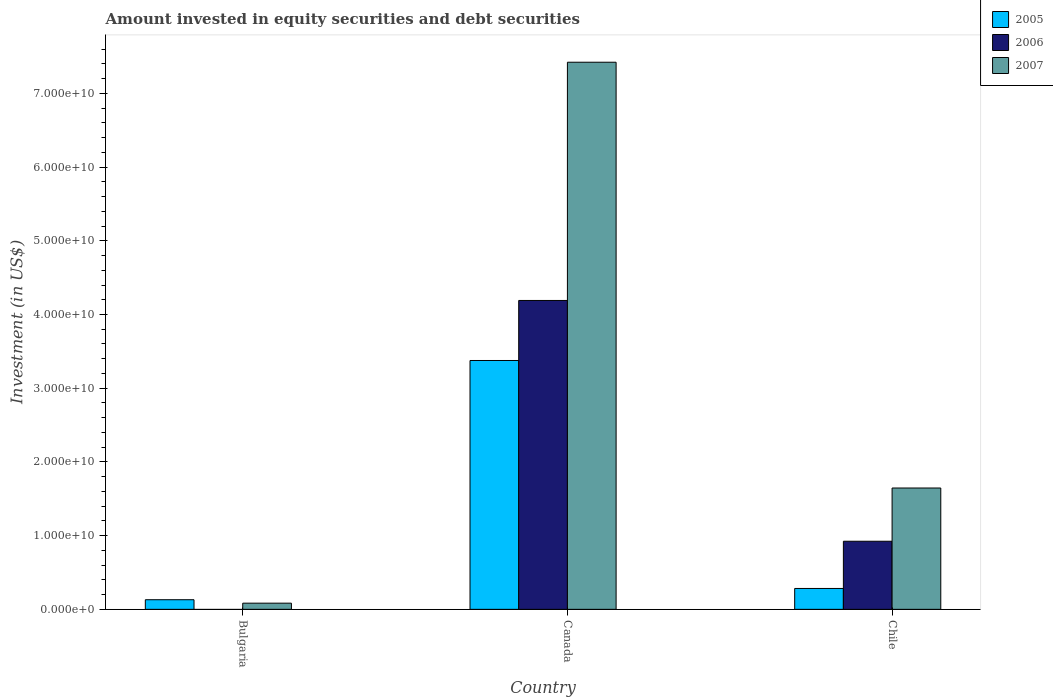How many different coloured bars are there?
Provide a short and direct response. 3. Are the number of bars per tick equal to the number of legend labels?
Provide a succinct answer. No. Are the number of bars on each tick of the X-axis equal?
Provide a succinct answer. No. How many bars are there on the 2nd tick from the left?
Provide a succinct answer. 3. How many bars are there on the 2nd tick from the right?
Provide a short and direct response. 3. What is the label of the 3rd group of bars from the left?
Offer a very short reply. Chile. In how many cases, is the number of bars for a given country not equal to the number of legend labels?
Your answer should be compact. 1. What is the amount invested in equity securities and debt securities in 2006 in Canada?
Your response must be concise. 4.19e+1. Across all countries, what is the maximum amount invested in equity securities and debt securities in 2006?
Give a very brief answer. 4.19e+1. Across all countries, what is the minimum amount invested in equity securities and debt securities in 2006?
Ensure brevity in your answer.  0. In which country was the amount invested in equity securities and debt securities in 2005 maximum?
Provide a succinct answer. Canada. What is the total amount invested in equity securities and debt securities in 2007 in the graph?
Offer a terse response. 9.15e+1. What is the difference between the amount invested in equity securities and debt securities in 2007 in Bulgaria and that in Chile?
Give a very brief answer. -1.56e+1. What is the difference between the amount invested in equity securities and debt securities in 2006 in Bulgaria and the amount invested in equity securities and debt securities in 2005 in Chile?
Provide a succinct answer. -2.83e+09. What is the average amount invested in equity securities and debt securities in 2006 per country?
Make the answer very short. 1.70e+1. What is the difference between the amount invested in equity securities and debt securities of/in 2007 and amount invested in equity securities and debt securities of/in 2006 in Chile?
Keep it short and to the point. 7.22e+09. In how many countries, is the amount invested in equity securities and debt securities in 2006 greater than 42000000000 US$?
Provide a short and direct response. 0. What is the ratio of the amount invested in equity securities and debt securities in 2006 in Canada to that in Chile?
Provide a succinct answer. 4.54. Is the amount invested in equity securities and debt securities in 2006 in Canada less than that in Chile?
Offer a terse response. No. What is the difference between the highest and the second highest amount invested in equity securities and debt securities in 2007?
Provide a short and direct response. -7.34e+1. What is the difference between the highest and the lowest amount invested in equity securities and debt securities in 2005?
Provide a succinct answer. 3.25e+1. Is the sum of the amount invested in equity securities and debt securities in 2005 in Canada and Chile greater than the maximum amount invested in equity securities and debt securities in 2006 across all countries?
Your answer should be very brief. No. How many countries are there in the graph?
Offer a very short reply. 3. What is the difference between two consecutive major ticks on the Y-axis?
Your response must be concise. 1.00e+1. Does the graph contain any zero values?
Your answer should be compact. Yes. How many legend labels are there?
Make the answer very short. 3. What is the title of the graph?
Your response must be concise. Amount invested in equity securities and debt securities. What is the label or title of the X-axis?
Provide a succinct answer. Country. What is the label or title of the Y-axis?
Give a very brief answer. Investment (in US$). What is the Investment (in US$) of 2005 in Bulgaria?
Ensure brevity in your answer.  1.30e+09. What is the Investment (in US$) in 2006 in Bulgaria?
Offer a terse response. 0. What is the Investment (in US$) of 2007 in Bulgaria?
Your answer should be very brief. 8.37e+08. What is the Investment (in US$) in 2005 in Canada?
Make the answer very short. 3.38e+1. What is the Investment (in US$) in 2006 in Canada?
Make the answer very short. 4.19e+1. What is the Investment (in US$) in 2007 in Canada?
Keep it short and to the point. 7.42e+1. What is the Investment (in US$) of 2005 in Chile?
Provide a short and direct response. 2.83e+09. What is the Investment (in US$) of 2006 in Chile?
Your answer should be very brief. 9.24e+09. What is the Investment (in US$) of 2007 in Chile?
Your answer should be compact. 1.65e+1. Across all countries, what is the maximum Investment (in US$) of 2005?
Provide a succinct answer. 3.38e+1. Across all countries, what is the maximum Investment (in US$) in 2006?
Give a very brief answer. 4.19e+1. Across all countries, what is the maximum Investment (in US$) of 2007?
Keep it short and to the point. 7.42e+1. Across all countries, what is the minimum Investment (in US$) of 2005?
Your response must be concise. 1.30e+09. Across all countries, what is the minimum Investment (in US$) of 2006?
Your response must be concise. 0. Across all countries, what is the minimum Investment (in US$) of 2007?
Your answer should be very brief. 8.37e+08. What is the total Investment (in US$) of 2005 in the graph?
Ensure brevity in your answer.  3.79e+1. What is the total Investment (in US$) of 2006 in the graph?
Ensure brevity in your answer.  5.11e+1. What is the total Investment (in US$) of 2007 in the graph?
Offer a terse response. 9.15e+1. What is the difference between the Investment (in US$) in 2005 in Bulgaria and that in Canada?
Ensure brevity in your answer.  -3.25e+1. What is the difference between the Investment (in US$) in 2007 in Bulgaria and that in Canada?
Your response must be concise. -7.34e+1. What is the difference between the Investment (in US$) in 2005 in Bulgaria and that in Chile?
Your response must be concise. -1.53e+09. What is the difference between the Investment (in US$) of 2007 in Bulgaria and that in Chile?
Your answer should be very brief. -1.56e+1. What is the difference between the Investment (in US$) in 2005 in Canada and that in Chile?
Provide a short and direct response. 3.09e+1. What is the difference between the Investment (in US$) in 2006 in Canada and that in Chile?
Give a very brief answer. 3.27e+1. What is the difference between the Investment (in US$) in 2007 in Canada and that in Chile?
Offer a very short reply. 5.78e+1. What is the difference between the Investment (in US$) in 2005 in Bulgaria and the Investment (in US$) in 2006 in Canada?
Your answer should be very brief. -4.06e+1. What is the difference between the Investment (in US$) of 2005 in Bulgaria and the Investment (in US$) of 2007 in Canada?
Make the answer very short. -7.29e+1. What is the difference between the Investment (in US$) in 2005 in Bulgaria and the Investment (in US$) in 2006 in Chile?
Make the answer very short. -7.93e+09. What is the difference between the Investment (in US$) of 2005 in Bulgaria and the Investment (in US$) of 2007 in Chile?
Ensure brevity in your answer.  -1.52e+1. What is the difference between the Investment (in US$) of 2005 in Canada and the Investment (in US$) of 2006 in Chile?
Ensure brevity in your answer.  2.45e+1. What is the difference between the Investment (in US$) in 2005 in Canada and the Investment (in US$) in 2007 in Chile?
Keep it short and to the point. 1.73e+1. What is the difference between the Investment (in US$) in 2006 in Canada and the Investment (in US$) in 2007 in Chile?
Ensure brevity in your answer.  2.54e+1. What is the average Investment (in US$) in 2005 per country?
Provide a short and direct response. 1.26e+1. What is the average Investment (in US$) in 2006 per country?
Provide a succinct answer. 1.70e+1. What is the average Investment (in US$) of 2007 per country?
Provide a short and direct response. 3.05e+1. What is the difference between the Investment (in US$) of 2005 and Investment (in US$) of 2007 in Bulgaria?
Give a very brief answer. 4.68e+08. What is the difference between the Investment (in US$) in 2005 and Investment (in US$) in 2006 in Canada?
Your answer should be compact. -8.14e+09. What is the difference between the Investment (in US$) of 2005 and Investment (in US$) of 2007 in Canada?
Your answer should be very brief. -4.05e+1. What is the difference between the Investment (in US$) of 2006 and Investment (in US$) of 2007 in Canada?
Make the answer very short. -3.23e+1. What is the difference between the Investment (in US$) in 2005 and Investment (in US$) in 2006 in Chile?
Make the answer very short. -6.41e+09. What is the difference between the Investment (in US$) of 2005 and Investment (in US$) of 2007 in Chile?
Provide a short and direct response. -1.36e+1. What is the difference between the Investment (in US$) in 2006 and Investment (in US$) in 2007 in Chile?
Offer a very short reply. -7.22e+09. What is the ratio of the Investment (in US$) of 2005 in Bulgaria to that in Canada?
Keep it short and to the point. 0.04. What is the ratio of the Investment (in US$) in 2007 in Bulgaria to that in Canada?
Give a very brief answer. 0.01. What is the ratio of the Investment (in US$) of 2005 in Bulgaria to that in Chile?
Make the answer very short. 0.46. What is the ratio of the Investment (in US$) in 2007 in Bulgaria to that in Chile?
Your response must be concise. 0.05. What is the ratio of the Investment (in US$) of 2005 in Canada to that in Chile?
Give a very brief answer. 11.92. What is the ratio of the Investment (in US$) of 2006 in Canada to that in Chile?
Your response must be concise. 4.54. What is the ratio of the Investment (in US$) of 2007 in Canada to that in Chile?
Provide a succinct answer. 4.51. What is the difference between the highest and the second highest Investment (in US$) of 2005?
Your response must be concise. 3.09e+1. What is the difference between the highest and the second highest Investment (in US$) of 2007?
Offer a terse response. 5.78e+1. What is the difference between the highest and the lowest Investment (in US$) of 2005?
Ensure brevity in your answer.  3.25e+1. What is the difference between the highest and the lowest Investment (in US$) in 2006?
Your answer should be very brief. 4.19e+1. What is the difference between the highest and the lowest Investment (in US$) in 2007?
Your response must be concise. 7.34e+1. 